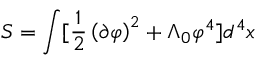Convert formula to latex. <formula><loc_0><loc_0><loc_500><loc_500>S = \int [ \frac { 1 } { 2 } \left ( \partial \varphi \right ) ^ { 2 } + \Lambda _ { 0 } \varphi ^ { 4 } ] d ^ { 4 } x</formula> 